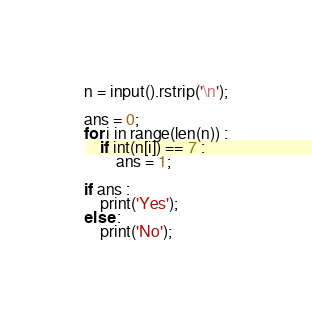Convert code to text. <code><loc_0><loc_0><loc_500><loc_500><_Python_>n = input().rstrip('\n');

ans = 0;
for i in range(len(n)) :
    if int(n[i]) == 7 :
        ans = 1;

if ans :
    print('Yes');
else :
    print('No');</code> 